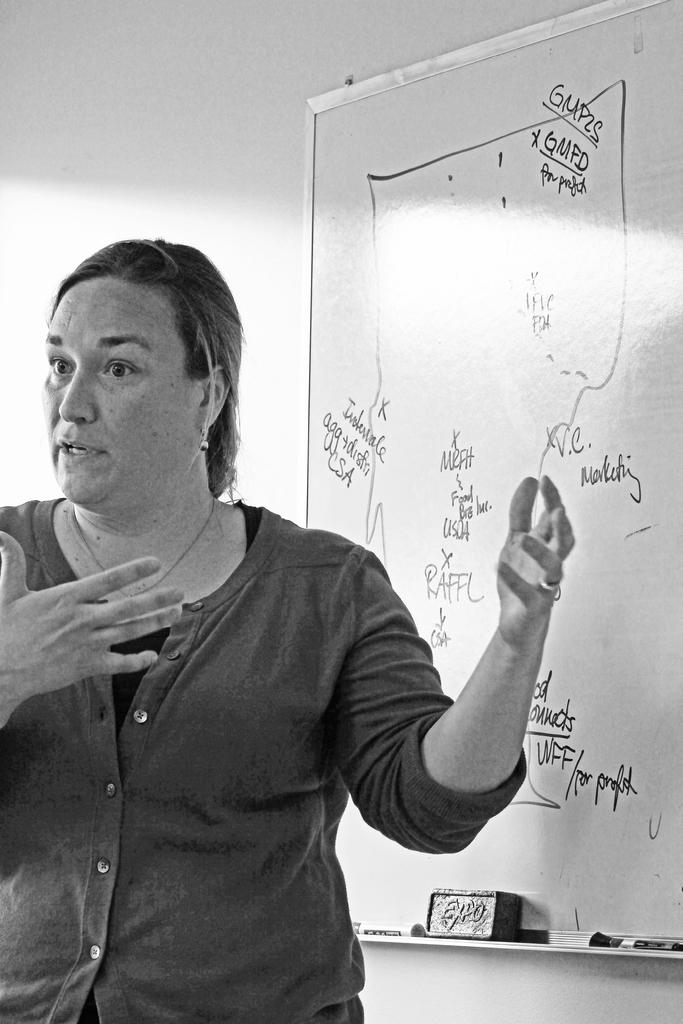Who is the main subject in the image? There is a woman in the image. What is the woman doing in the image? The woman is explaining something. What is behind the woman in the image? There is a whiteboard behind the woman. What can be seen on the whiteboard? Something is written on the whiteboard. What is visible in the background of the image? There is a wall in the background of the image. What type of trucks can be seen in the image? There are no trucks present in the image. What is the harmony between the woman and the whiteboard in the image? The concept of harmony does not apply to the relationship between the woman and the whiteboard in the image, as it is a static scene. 